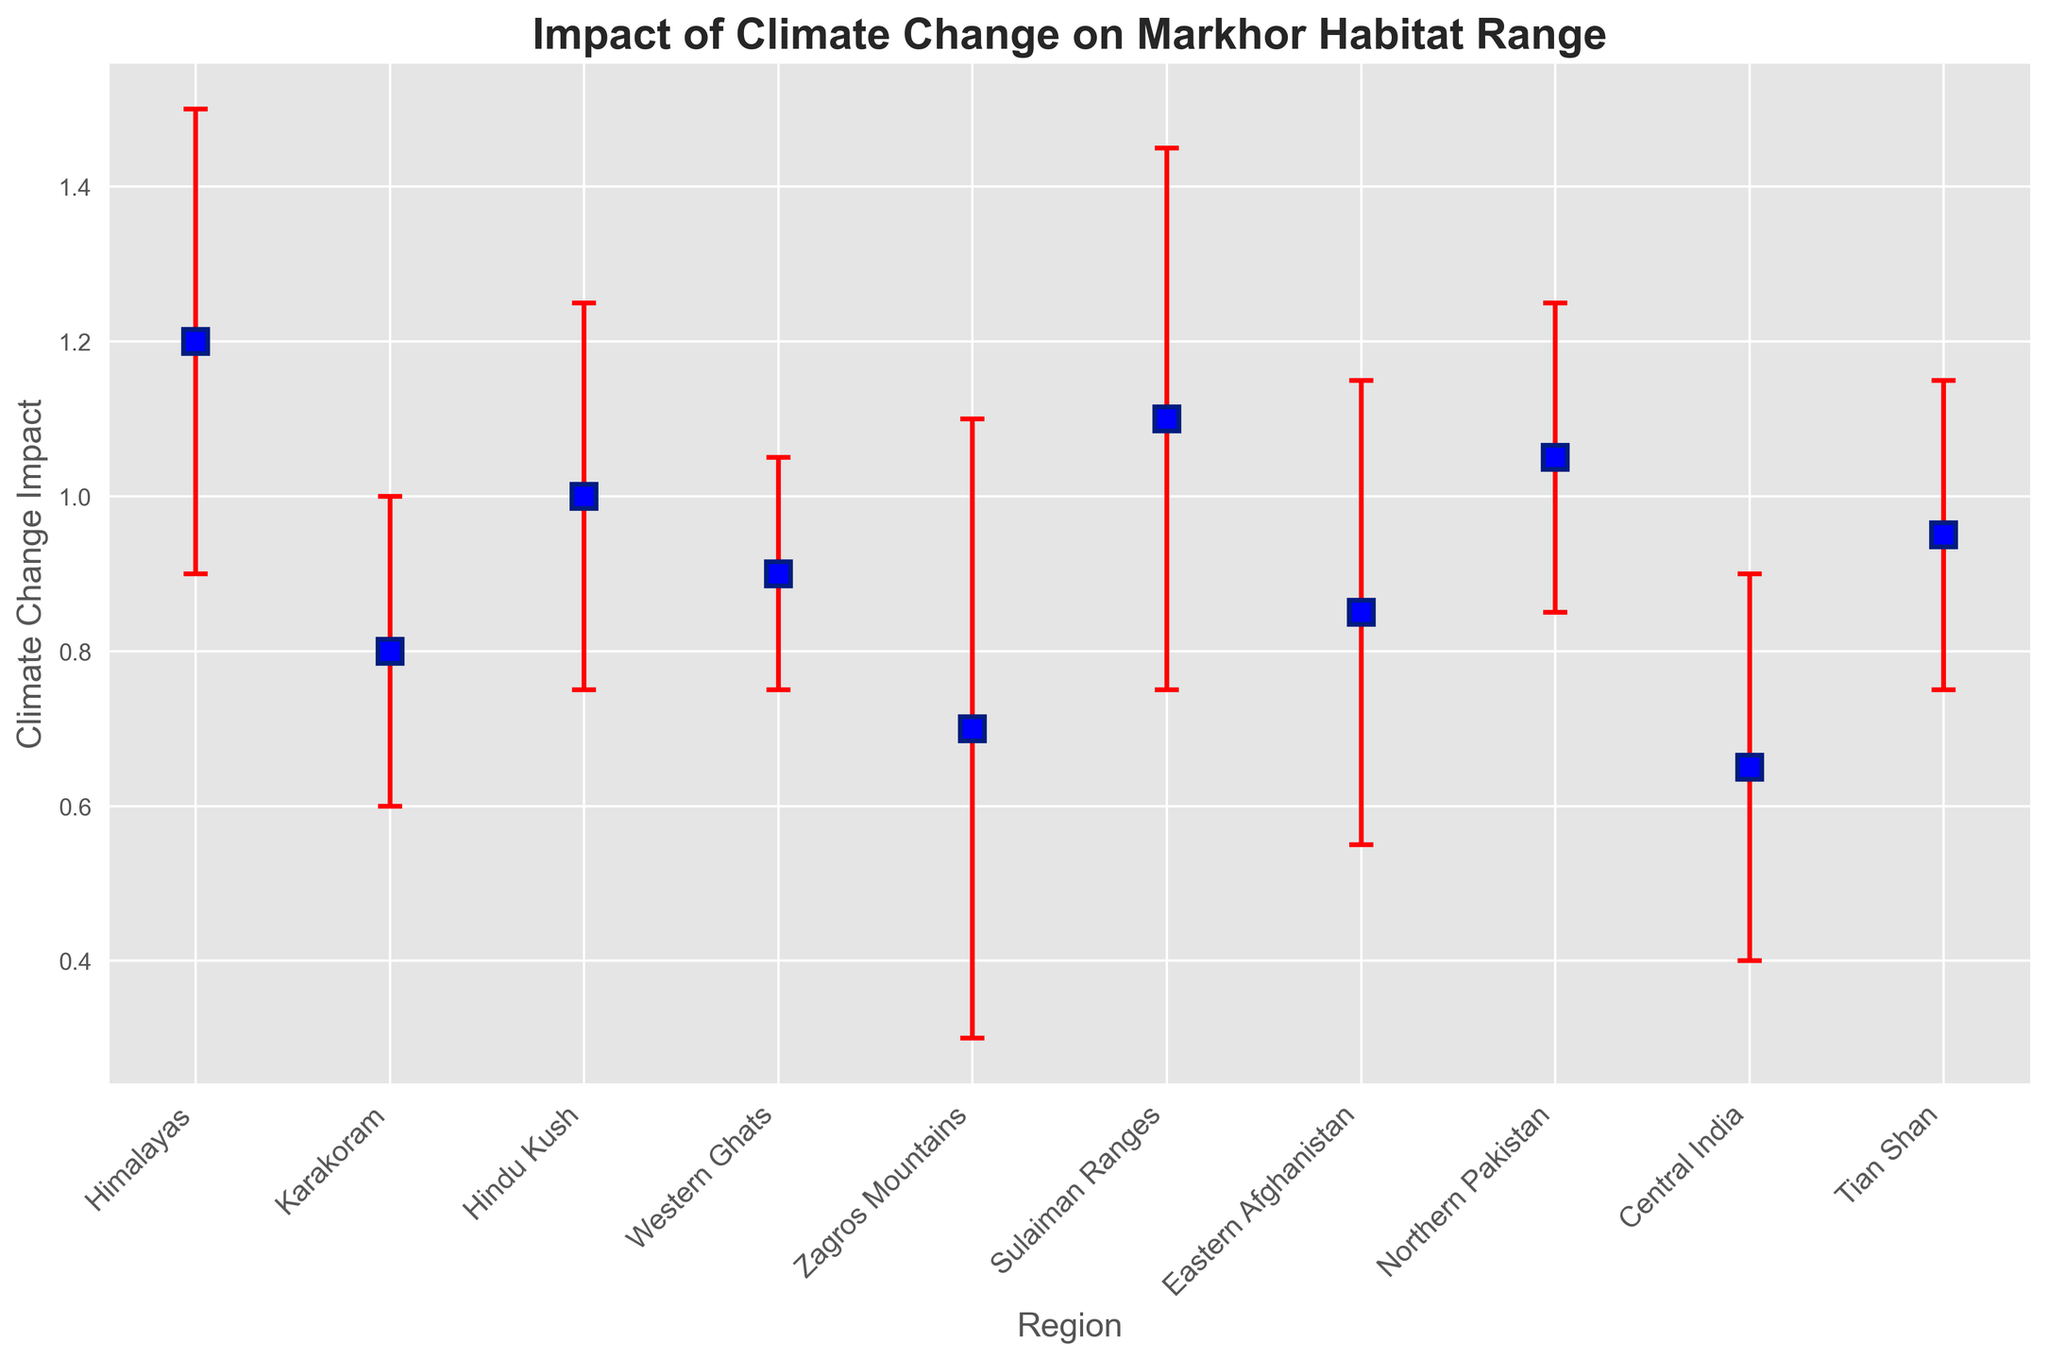What region shows the highest impact of climate change on Markhor habitat range? Look at the vertical error bars and the markers representing the impact values on the y-axis. The highest marker is at the Himalayas with an impact of 1.2.
Answer: Himalayas Which regions have an impact value that is less than 1.0? Check the markers below the 1.0 mark on the y-axis. These regions are Karakoram, Western Ghats, Zagros Mountains, Eastern Afghanistan, and Central India.
Answer: Karakoram, Western Ghats, Zagros Mountains, Eastern Afghanistan, Central India Compare the climate change impact on Markhor habitats in the Himalayas and the Zagros Mountains. Compare the markers for the Himalayas and the Zagros Mountains. Himalayas has an impact of 1.2 whereas Zagros Mountains has 0.7.
Answer: Himalayas has a higher impact than Zagros Mountains Which region has the largest error bar? Look at the length of the error bars. The Zagros Mountains region has the largest error bar indicating a standard deviation of 0.4.
Answer: Zagros Mountains What's the average climate change impact across all regions? Sum up all the impact values: 1.2 + 0.8 + 1.0 + 0.9 + 0.7 + 1.1 + 0.85 + 1.05 + 0.65 + 0.95 = 9.2. Divide by the number of regions (10): 9.2 / 10 = 0.92
Answer: 0.92 Which regions have error bars extending above 1.0? Identify the regions where the upper end of the error bar (impact + std. dev.) exceeds 1.0. These are the Himalayas (1.2 + 0.3), Hindu Kush (1.0 + 0.25), Sulaiman Ranges (1.1 + 0.35), and Northern Pakistan (1.05 + 0.2).
Answer: Himalayas, Hindu Kush, Sulaiman Ranges, Northern Pakistan What is the difference in the impact of climate change between the region with the highest impact and the region with the lowest impact? The highest impact is in the Himalayas (1.2) and the lowest is in Central India (0.65). The difference is 1.2 - 0.65 = 0.55.
Answer: 0.55 